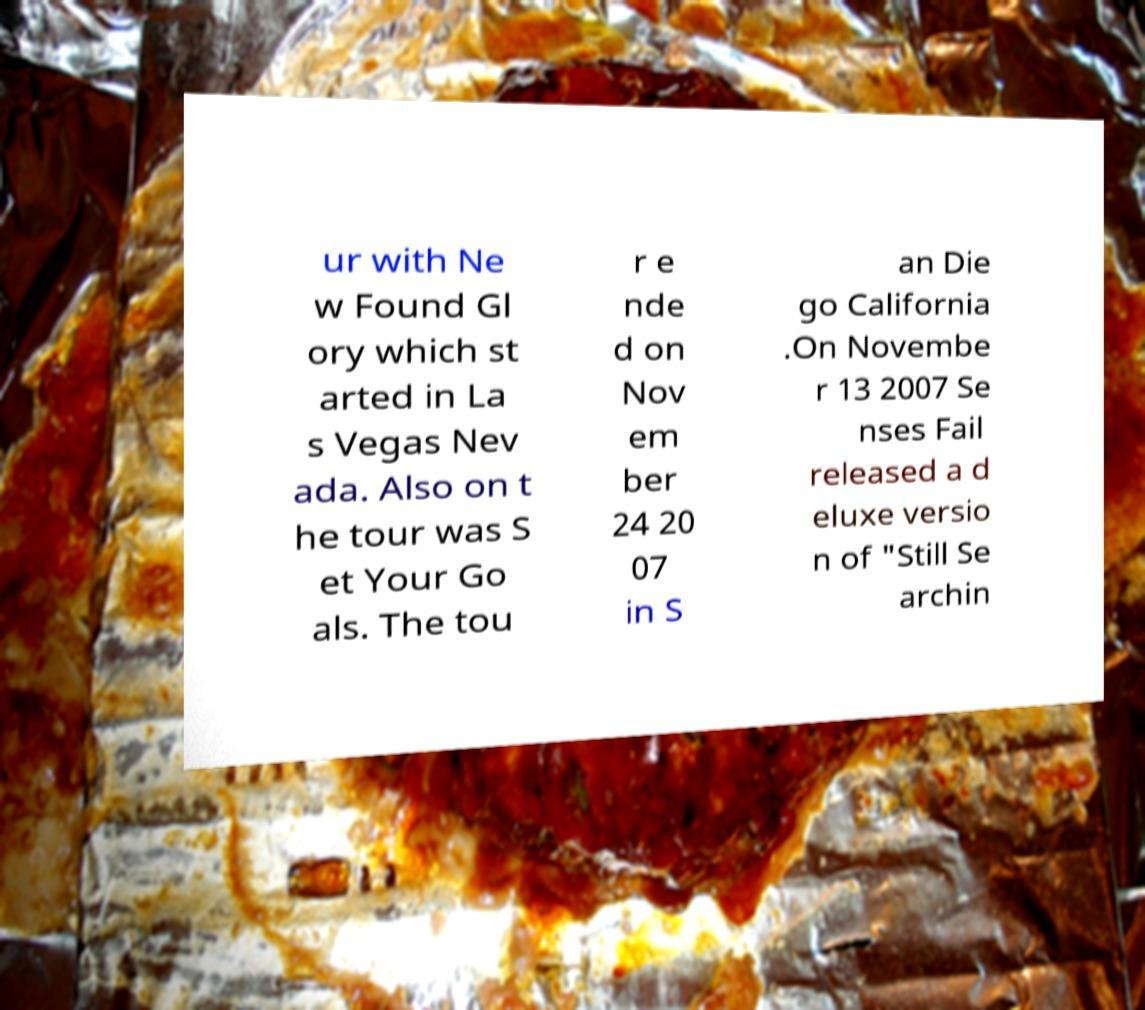Can you accurately transcribe the text from the provided image for me? ur with Ne w Found Gl ory which st arted in La s Vegas Nev ada. Also on t he tour was S et Your Go als. The tou r e nde d on Nov em ber 24 20 07 in S an Die go California .On Novembe r 13 2007 Se nses Fail released a d eluxe versio n of "Still Se archin 